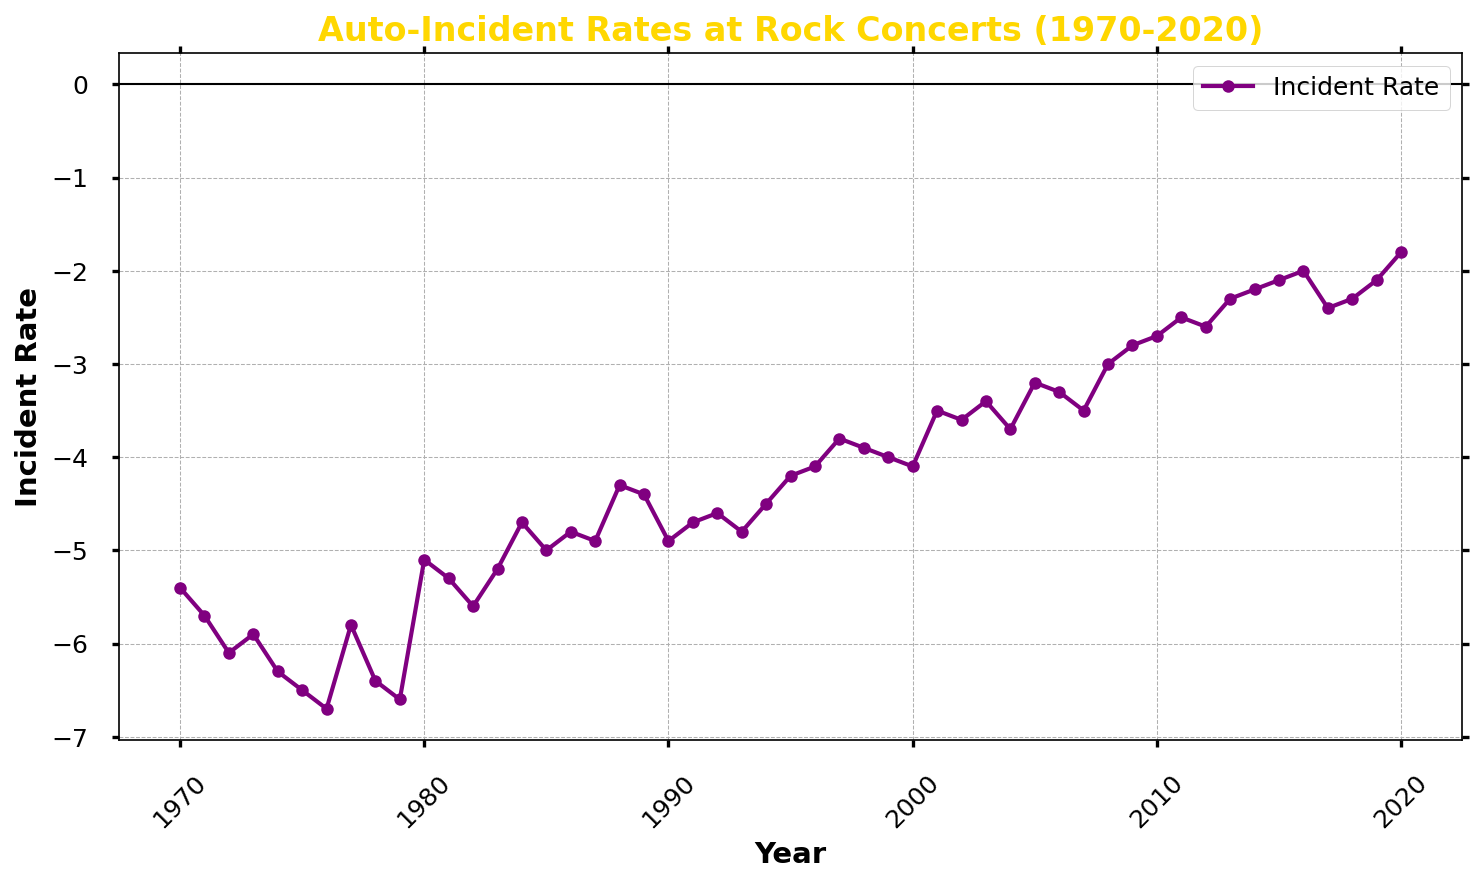What's the average auto-incident rate in the 1970s? First, note the years in the 1970s: 1970 through 1979. Then sum the rates for these years: -5.4, -5.7, -6.1, -5.9, -6.3, -6.5, -6.7, -5.8, -6.4, -6.6. The total is -61.4. There are 10 years, thus the average is -61.4 / 10 = -6.14
Answer: -6.14 In which year did the auto-incident rate first drop below -5? Observe the trend of the line and identify the first year where the rate is below -5. This happens in 1975 where the rate is -6.5.
Answer: 1975 Which year had the highest auto-incident rate? Identify the highest point on the line chart. The highest rate is -1.8 in 2020.
Answer: 2020 By how much did the auto-incident rate decrease from 2000 to 2020? Subtract the rate in 2000 from the rate in 2020: -1.8 - (-4.1) = -1.8 + 4.1 = 2.3
Answer: 2.3 Which decade had the most significant decrease in auto-incident rates? Compare the rates at the start and end of each decade. The 1980s start at -5.1 (1980) and end at -4.4 (1989) with a decrease of 0.7. The 1990s start at -4.9 (1990) and end at -4.0 (1999) with a decrease of 0.9. The 2000s start at -4.1 (2000) and end at -2.7 (2010) with a decrease of 1.4. The 2010s start at -2.7 (2010) and end at -2.1 (2019) with a decrease of 0.6. Thus, the 2000s had the most significant decrease.
Answer: 2000s When did the auto-incident rate experience the most significant single-year drop? Examine the line chart for the steepest decline between two consecutive years. The largest drop appears between 1976 (-6.7) and 1977 (-5.8), resulting in a change of 0.9.
Answer: 1976 to 1977 What is the general trend of the auto-incident rate from the 1970s to 2020? Look at the overall direction of the line from left to right. The general trend shows a consistent decrease in the auto-incident rate from the 1970s to 2020.
Answer: Decreasing How many times did the auto-incident rate increase from one year to the next between 1970 and 2020? Count the number of instances where the rate increased compared to the previous year. In the data, this occurs in the following years: 1980, 1983, 1984, 1985, 1987, 1992, 1995, 1997, 2000, 2003, 2005, 2008, 2010, 2013, 2018, and 2020. A total of 16 increases.
Answer: 16 Which year's auto-incident rate was closest to the average rate of the 1980s? First, find the average incident rate for the 1980s: (-5.1 + -5.3 + -5.6 + -5.2 + -4.7 + -5.0 + -4.8 + -4.9 + -4.3 + -4.4) / 10 = -4.93. Next, check for the year with the rate closest to -4.93. The year with a rate closest to -4.93 in the 1980s is 1988 with -4.3.
Answer: 1988 